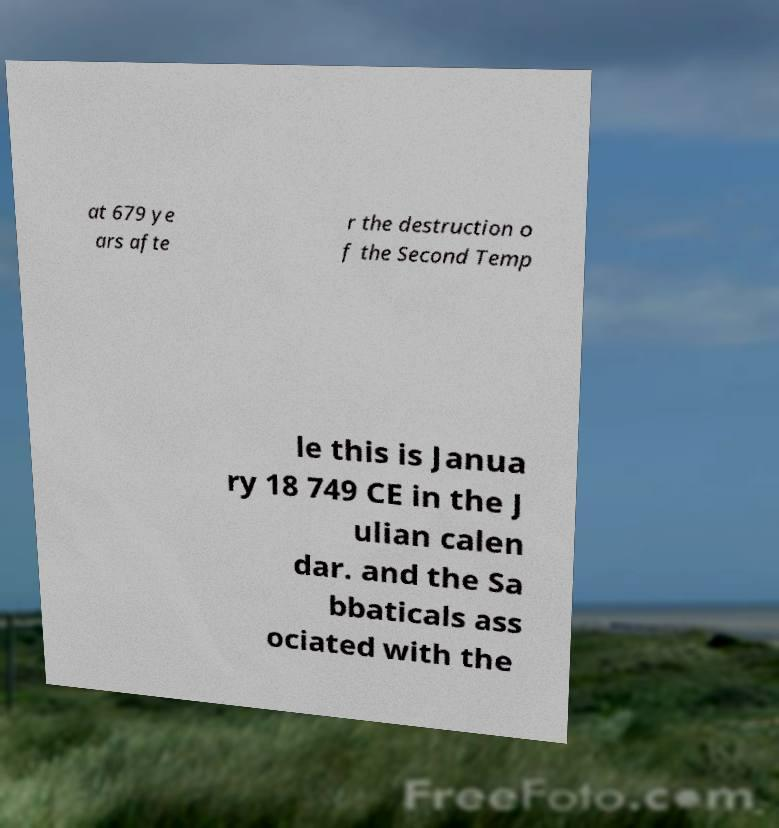Please identify and transcribe the text found in this image. at 679 ye ars afte r the destruction o f the Second Temp le this is Janua ry 18 749 CE in the J ulian calen dar. and the Sa bbaticals ass ociated with the 